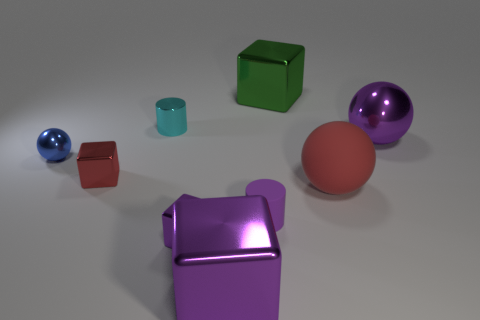Is there a gray object?
Offer a very short reply. No. What color is the metal cylinder that is the same size as the blue sphere?
Make the answer very short. Cyan. How many green objects have the same shape as the red shiny object?
Provide a short and direct response. 1. Do the big sphere that is behind the big red matte sphere and the cyan cylinder have the same material?
Offer a very short reply. Yes. What number of blocks are either red metal objects or big objects?
Make the answer very short. 3. What shape is the thing in front of the purple cube behind the large purple shiny object that is in front of the small shiny ball?
Provide a succinct answer. Cube. The rubber thing that is the same color as the large shiny sphere is what shape?
Keep it short and to the point. Cylinder. How many red balls have the same size as the rubber cylinder?
Your response must be concise. 0. There is a large purple object to the right of the purple rubber cylinder; is there a metal thing in front of it?
Your response must be concise. Yes. What number of things are either large green shiny things or tiny yellow rubber cylinders?
Offer a very short reply. 1. 